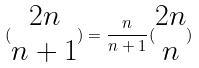<formula> <loc_0><loc_0><loc_500><loc_500>( \begin{matrix} 2 n \\ n + 1 \end{matrix} ) = \frac { n } { n + 1 } ( \begin{matrix} 2 n \\ n \end{matrix} )</formula> 